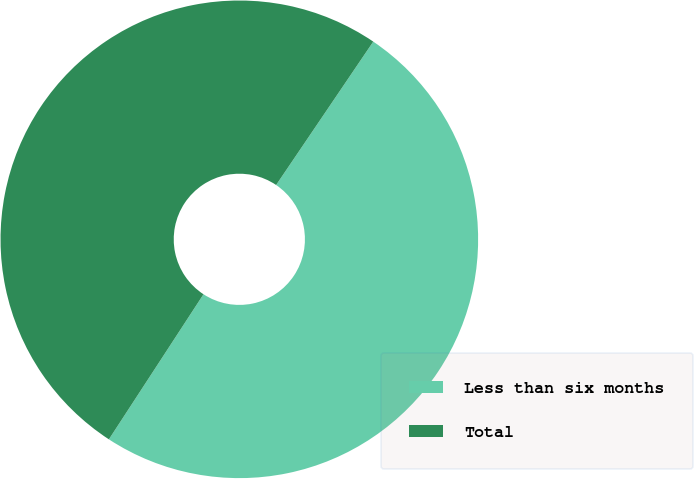Convert chart to OTSL. <chart><loc_0><loc_0><loc_500><loc_500><pie_chart><fcel>Less than six months<fcel>Total<nl><fcel>49.72%<fcel>50.28%<nl></chart> 